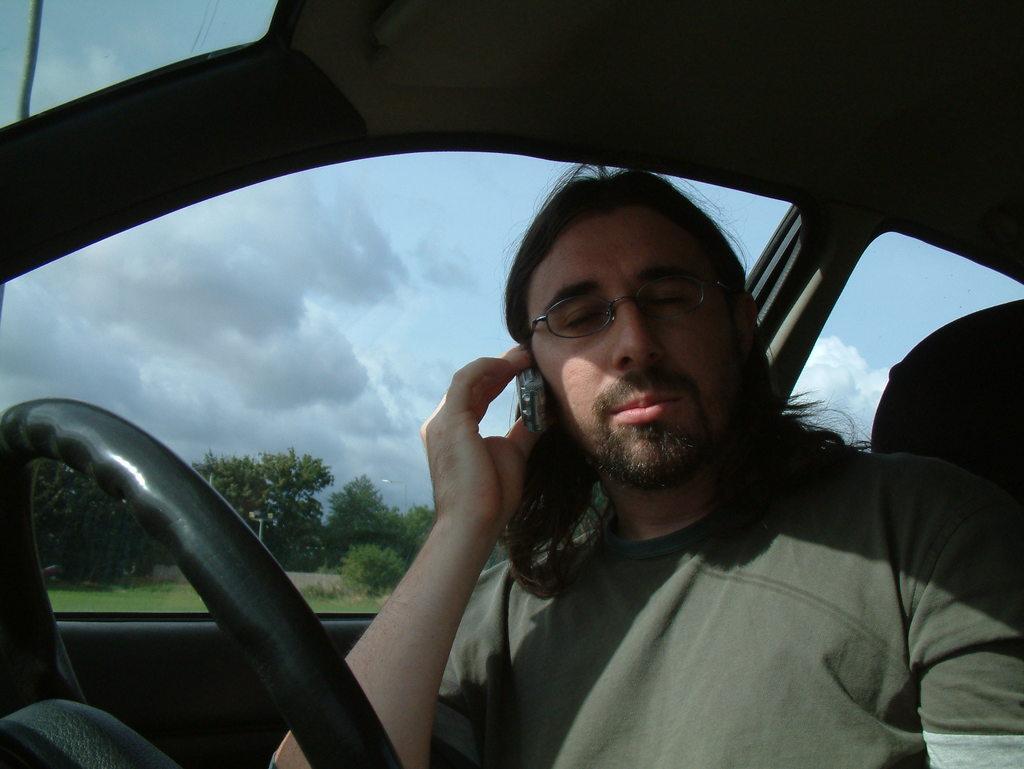Please provide a concise description of this image. In this image there is a person holding a mobile phone, wearing goggles and sitting in the car, there are few trees, a pole and some clouds in the sky. 